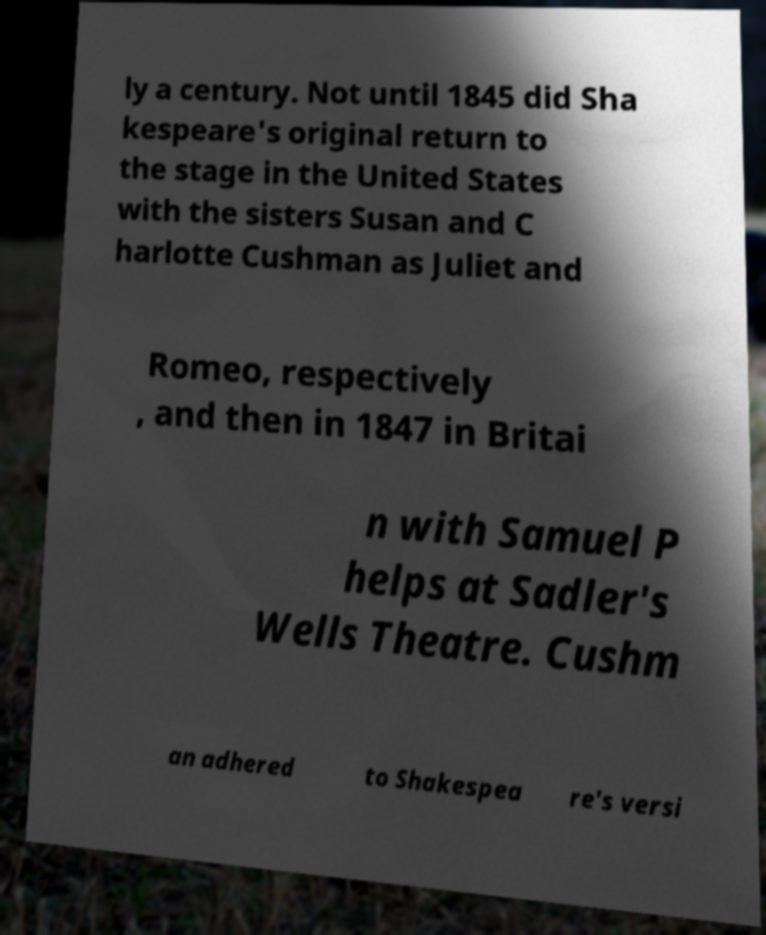Can you read and provide the text displayed in the image?This photo seems to have some interesting text. Can you extract and type it out for me? ly a century. Not until 1845 did Sha kespeare's original return to the stage in the United States with the sisters Susan and C harlotte Cushman as Juliet and Romeo, respectively , and then in 1847 in Britai n with Samuel P helps at Sadler's Wells Theatre. Cushm an adhered to Shakespea re's versi 